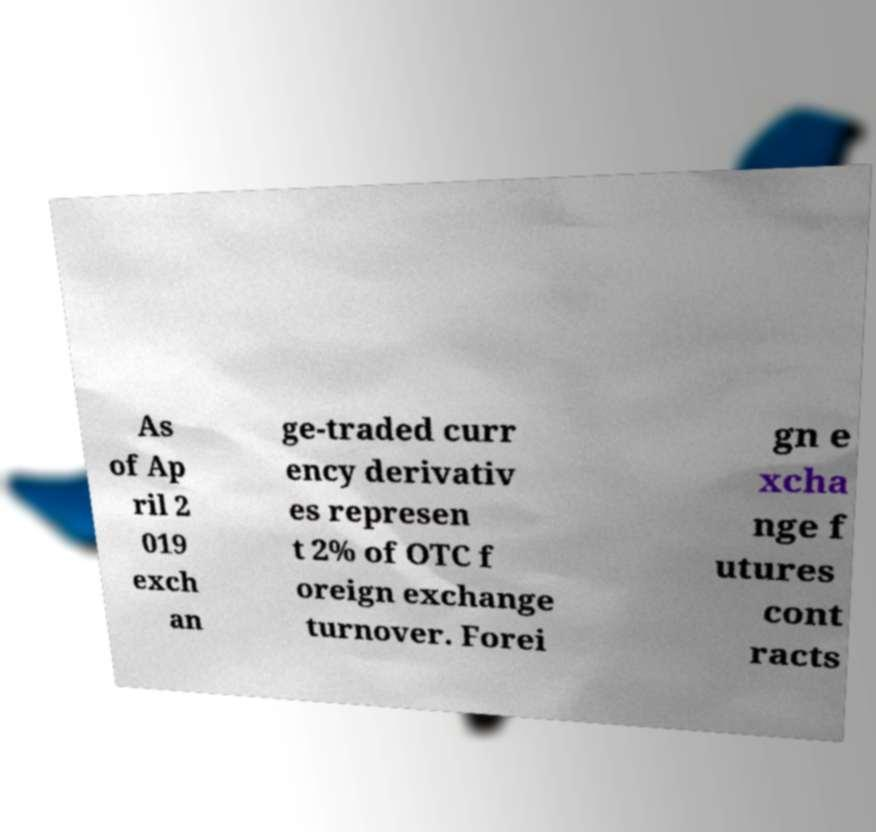Please identify and transcribe the text found in this image. As of Ap ril 2 019 exch an ge-traded curr ency derivativ es represen t 2% of OTC f oreign exchange turnover. Forei gn e xcha nge f utures cont racts 